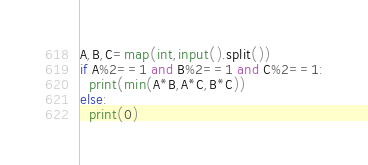Convert code to text. <code><loc_0><loc_0><loc_500><loc_500><_Python_>A,B,C=map(int,input().split())
if A%2==1 and B%2==1 and C%2==1:
  print(min(A*B,A*C,B*C))
else:
  print(0)</code> 